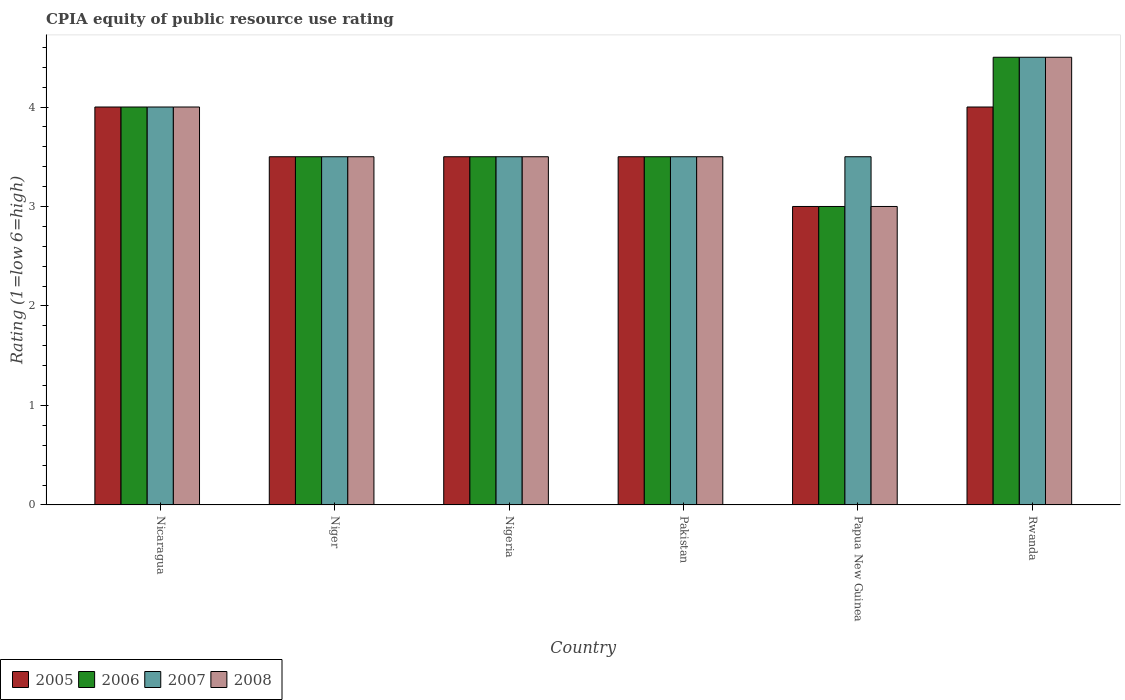Are the number of bars per tick equal to the number of legend labels?
Offer a terse response. Yes. Are the number of bars on each tick of the X-axis equal?
Ensure brevity in your answer.  Yes. How many bars are there on the 6th tick from the left?
Provide a succinct answer. 4. What is the label of the 5th group of bars from the left?
Provide a succinct answer. Papua New Guinea. In how many cases, is the number of bars for a given country not equal to the number of legend labels?
Provide a succinct answer. 0. What is the CPIA rating in 2005 in Rwanda?
Provide a short and direct response. 4. Across all countries, what is the minimum CPIA rating in 2006?
Provide a succinct answer. 3. In which country was the CPIA rating in 2005 maximum?
Offer a terse response. Nicaragua. In which country was the CPIA rating in 2006 minimum?
Keep it short and to the point. Papua New Guinea. What is the total CPIA rating in 2006 in the graph?
Provide a short and direct response. 22. What is the difference between the CPIA rating in 2007 in Nigeria and that in Rwanda?
Your answer should be very brief. -1. What is the difference between the CPIA rating in 2005 in Pakistan and the CPIA rating in 2006 in Niger?
Offer a very short reply. 0. What is the average CPIA rating in 2006 per country?
Provide a succinct answer. 3.67. What is the difference between the CPIA rating of/in 2006 and CPIA rating of/in 2005 in Pakistan?
Offer a very short reply. 0. What is the ratio of the CPIA rating in 2007 in Nicaragua to that in Niger?
Give a very brief answer. 1.14. Is the CPIA rating in 2008 in Niger less than that in Rwanda?
Provide a short and direct response. Yes. Is the sum of the CPIA rating in 2005 in Nicaragua and Niger greater than the maximum CPIA rating in 2007 across all countries?
Give a very brief answer. Yes. What does the 1st bar from the left in Pakistan represents?
Keep it short and to the point. 2005. What does the 1st bar from the right in Pakistan represents?
Offer a very short reply. 2008. How many bars are there?
Give a very brief answer. 24. How many countries are there in the graph?
Keep it short and to the point. 6. What is the difference between two consecutive major ticks on the Y-axis?
Provide a succinct answer. 1. Does the graph contain any zero values?
Your response must be concise. No. What is the title of the graph?
Provide a succinct answer. CPIA equity of public resource use rating. What is the label or title of the X-axis?
Offer a very short reply. Country. What is the Rating (1=low 6=high) in 2005 in Nicaragua?
Provide a succinct answer. 4. What is the Rating (1=low 6=high) in 2007 in Nicaragua?
Your response must be concise. 4. What is the Rating (1=low 6=high) of 2005 in Niger?
Your answer should be compact. 3.5. What is the Rating (1=low 6=high) in 2006 in Niger?
Give a very brief answer. 3.5. What is the Rating (1=low 6=high) of 2007 in Niger?
Offer a terse response. 3.5. What is the Rating (1=low 6=high) in 2006 in Nigeria?
Offer a terse response. 3.5. What is the Rating (1=low 6=high) in 2008 in Nigeria?
Keep it short and to the point. 3.5. What is the Rating (1=low 6=high) of 2005 in Pakistan?
Provide a succinct answer. 3.5. What is the Rating (1=low 6=high) in 2005 in Papua New Guinea?
Keep it short and to the point. 3. What is the Rating (1=low 6=high) of 2006 in Papua New Guinea?
Make the answer very short. 3. What is the Rating (1=low 6=high) in 2007 in Papua New Guinea?
Your answer should be compact. 3.5. What is the Rating (1=low 6=high) of 2008 in Papua New Guinea?
Give a very brief answer. 3. What is the Rating (1=low 6=high) of 2006 in Rwanda?
Provide a short and direct response. 4.5. Across all countries, what is the maximum Rating (1=low 6=high) in 2007?
Provide a short and direct response. 4.5. Across all countries, what is the maximum Rating (1=low 6=high) in 2008?
Offer a terse response. 4.5. Across all countries, what is the minimum Rating (1=low 6=high) of 2005?
Keep it short and to the point. 3. Across all countries, what is the minimum Rating (1=low 6=high) of 2006?
Keep it short and to the point. 3. Across all countries, what is the minimum Rating (1=low 6=high) of 2007?
Offer a terse response. 3.5. Across all countries, what is the minimum Rating (1=low 6=high) in 2008?
Your response must be concise. 3. What is the total Rating (1=low 6=high) of 2008 in the graph?
Ensure brevity in your answer.  22. What is the difference between the Rating (1=low 6=high) of 2005 in Nicaragua and that in Niger?
Your response must be concise. 0.5. What is the difference between the Rating (1=low 6=high) in 2007 in Nicaragua and that in Niger?
Make the answer very short. 0.5. What is the difference between the Rating (1=low 6=high) of 2005 in Nicaragua and that in Nigeria?
Provide a succinct answer. 0.5. What is the difference between the Rating (1=low 6=high) in 2007 in Nicaragua and that in Nigeria?
Keep it short and to the point. 0.5. What is the difference between the Rating (1=low 6=high) in 2008 in Nicaragua and that in Nigeria?
Provide a succinct answer. 0.5. What is the difference between the Rating (1=low 6=high) in 2006 in Nicaragua and that in Pakistan?
Make the answer very short. 0.5. What is the difference between the Rating (1=low 6=high) of 2007 in Nicaragua and that in Pakistan?
Make the answer very short. 0.5. What is the difference between the Rating (1=low 6=high) in 2008 in Nicaragua and that in Pakistan?
Make the answer very short. 0.5. What is the difference between the Rating (1=low 6=high) of 2006 in Nicaragua and that in Papua New Guinea?
Make the answer very short. 1. What is the difference between the Rating (1=low 6=high) of 2007 in Nicaragua and that in Papua New Guinea?
Give a very brief answer. 0.5. What is the difference between the Rating (1=low 6=high) in 2005 in Nicaragua and that in Rwanda?
Offer a terse response. 0. What is the difference between the Rating (1=low 6=high) in 2008 in Nicaragua and that in Rwanda?
Your answer should be very brief. -0.5. What is the difference between the Rating (1=low 6=high) of 2007 in Niger and that in Nigeria?
Offer a terse response. 0. What is the difference between the Rating (1=low 6=high) of 2005 in Niger and that in Pakistan?
Your response must be concise. 0. What is the difference between the Rating (1=low 6=high) in 2006 in Niger and that in Pakistan?
Offer a very short reply. 0. What is the difference between the Rating (1=low 6=high) in 2005 in Niger and that in Papua New Guinea?
Give a very brief answer. 0.5. What is the difference between the Rating (1=low 6=high) in 2007 in Niger and that in Papua New Guinea?
Offer a very short reply. 0. What is the difference between the Rating (1=low 6=high) in 2006 in Niger and that in Rwanda?
Provide a short and direct response. -1. What is the difference between the Rating (1=low 6=high) in 2008 in Niger and that in Rwanda?
Ensure brevity in your answer.  -1. What is the difference between the Rating (1=low 6=high) in 2005 in Nigeria and that in Pakistan?
Keep it short and to the point. 0. What is the difference between the Rating (1=low 6=high) of 2006 in Nigeria and that in Pakistan?
Your answer should be very brief. 0. What is the difference between the Rating (1=low 6=high) of 2007 in Nigeria and that in Pakistan?
Offer a terse response. 0. What is the difference between the Rating (1=low 6=high) of 2005 in Nigeria and that in Papua New Guinea?
Your answer should be compact. 0.5. What is the difference between the Rating (1=low 6=high) in 2007 in Nigeria and that in Papua New Guinea?
Provide a short and direct response. 0. What is the difference between the Rating (1=low 6=high) in 2006 in Nigeria and that in Rwanda?
Provide a succinct answer. -1. What is the difference between the Rating (1=low 6=high) in 2008 in Nigeria and that in Rwanda?
Your answer should be very brief. -1. What is the difference between the Rating (1=low 6=high) of 2005 in Pakistan and that in Papua New Guinea?
Provide a short and direct response. 0.5. What is the difference between the Rating (1=low 6=high) of 2007 in Pakistan and that in Papua New Guinea?
Offer a terse response. 0. What is the difference between the Rating (1=low 6=high) in 2005 in Pakistan and that in Rwanda?
Give a very brief answer. -0.5. What is the difference between the Rating (1=low 6=high) of 2007 in Pakistan and that in Rwanda?
Your answer should be compact. -1. What is the difference between the Rating (1=low 6=high) of 2008 in Pakistan and that in Rwanda?
Your answer should be very brief. -1. What is the difference between the Rating (1=low 6=high) in 2005 in Papua New Guinea and that in Rwanda?
Offer a very short reply. -1. What is the difference between the Rating (1=low 6=high) in 2006 in Papua New Guinea and that in Rwanda?
Your answer should be very brief. -1.5. What is the difference between the Rating (1=low 6=high) of 2007 in Papua New Guinea and that in Rwanda?
Ensure brevity in your answer.  -1. What is the difference between the Rating (1=low 6=high) of 2005 in Nicaragua and the Rating (1=low 6=high) of 2006 in Niger?
Offer a very short reply. 0.5. What is the difference between the Rating (1=low 6=high) of 2005 in Nicaragua and the Rating (1=low 6=high) of 2007 in Niger?
Give a very brief answer. 0.5. What is the difference between the Rating (1=low 6=high) in 2006 in Nicaragua and the Rating (1=low 6=high) in 2008 in Niger?
Make the answer very short. 0.5. What is the difference between the Rating (1=low 6=high) of 2007 in Nicaragua and the Rating (1=low 6=high) of 2008 in Niger?
Your answer should be compact. 0.5. What is the difference between the Rating (1=low 6=high) of 2005 in Nicaragua and the Rating (1=low 6=high) of 2007 in Nigeria?
Ensure brevity in your answer.  0.5. What is the difference between the Rating (1=low 6=high) in 2005 in Nicaragua and the Rating (1=low 6=high) in 2006 in Pakistan?
Your response must be concise. 0.5. What is the difference between the Rating (1=low 6=high) of 2006 in Nicaragua and the Rating (1=low 6=high) of 2007 in Pakistan?
Your answer should be very brief. 0.5. What is the difference between the Rating (1=low 6=high) of 2007 in Nicaragua and the Rating (1=low 6=high) of 2008 in Pakistan?
Ensure brevity in your answer.  0.5. What is the difference between the Rating (1=low 6=high) in 2005 in Nicaragua and the Rating (1=low 6=high) in 2006 in Papua New Guinea?
Provide a succinct answer. 1. What is the difference between the Rating (1=low 6=high) of 2005 in Nicaragua and the Rating (1=low 6=high) of 2007 in Papua New Guinea?
Provide a succinct answer. 0.5. What is the difference between the Rating (1=low 6=high) in 2005 in Nicaragua and the Rating (1=low 6=high) in 2008 in Papua New Guinea?
Your answer should be very brief. 1. What is the difference between the Rating (1=low 6=high) in 2005 in Nicaragua and the Rating (1=low 6=high) in 2006 in Rwanda?
Your response must be concise. -0.5. What is the difference between the Rating (1=low 6=high) of 2005 in Nicaragua and the Rating (1=low 6=high) of 2007 in Rwanda?
Provide a short and direct response. -0.5. What is the difference between the Rating (1=low 6=high) of 2005 in Nicaragua and the Rating (1=low 6=high) of 2008 in Rwanda?
Ensure brevity in your answer.  -0.5. What is the difference between the Rating (1=low 6=high) of 2006 in Nicaragua and the Rating (1=low 6=high) of 2007 in Rwanda?
Offer a very short reply. -0.5. What is the difference between the Rating (1=low 6=high) in 2006 in Nicaragua and the Rating (1=low 6=high) in 2008 in Rwanda?
Ensure brevity in your answer.  -0.5. What is the difference between the Rating (1=low 6=high) in 2005 in Niger and the Rating (1=low 6=high) in 2007 in Nigeria?
Offer a very short reply. 0. What is the difference between the Rating (1=low 6=high) in 2005 in Niger and the Rating (1=low 6=high) in 2008 in Nigeria?
Provide a succinct answer. 0. What is the difference between the Rating (1=low 6=high) of 2006 in Niger and the Rating (1=low 6=high) of 2007 in Nigeria?
Ensure brevity in your answer.  0. What is the difference between the Rating (1=low 6=high) of 2007 in Niger and the Rating (1=low 6=high) of 2008 in Nigeria?
Keep it short and to the point. 0. What is the difference between the Rating (1=low 6=high) in 2005 in Niger and the Rating (1=low 6=high) in 2006 in Pakistan?
Your response must be concise. 0. What is the difference between the Rating (1=low 6=high) of 2005 in Niger and the Rating (1=low 6=high) of 2007 in Pakistan?
Keep it short and to the point. 0. What is the difference between the Rating (1=low 6=high) in 2006 in Niger and the Rating (1=low 6=high) in 2007 in Pakistan?
Ensure brevity in your answer.  0. What is the difference between the Rating (1=low 6=high) in 2007 in Niger and the Rating (1=low 6=high) in 2008 in Pakistan?
Provide a short and direct response. 0. What is the difference between the Rating (1=low 6=high) in 2005 in Niger and the Rating (1=low 6=high) in 2006 in Papua New Guinea?
Offer a terse response. 0.5. What is the difference between the Rating (1=low 6=high) in 2006 in Niger and the Rating (1=low 6=high) in 2008 in Papua New Guinea?
Ensure brevity in your answer.  0.5. What is the difference between the Rating (1=low 6=high) in 2005 in Niger and the Rating (1=low 6=high) in 2006 in Rwanda?
Your answer should be compact. -1. What is the difference between the Rating (1=low 6=high) of 2005 in Niger and the Rating (1=low 6=high) of 2007 in Rwanda?
Ensure brevity in your answer.  -1. What is the difference between the Rating (1=low 6=high) in 2005 in Niger and the Rating (1=low 6=high) in 2008 in Rwanda?
Make the answer very short. -1. What is the difference between the Rating (1=low 6=high) of 2006 in Niger and the Rating (1=low 6=high) of 2008 in Rwanda?
Provide a short and direct response. -1. What is the difference between the Rating (1=low 6=high) in 2007 in Niger and the Rating (1=low 6=high) in 2008 in Rwanda?
Offer a very short reply. -1. What is the difference between the Rating (1=low 6=high) of 2005 in Nigeria and the Rating (1=low 6=high) of 2006 in Pakistan?
Your response must be concise. 0. What is the difference between the Rating (1=low 6=high) in 2005 in Nigeria and the Rating (1=low 6=high) in 2007 in Pakistan?
Make the answer very short. 0. What is the difference between the Rating (1=low 6=high) of 2006 in Nigeria and the Rating (1=low 6=high) of 2008 in Pakistan?
Offer a terse response. 0. What is the difference between the Rating (1=low 6=high) of 2007 in Nigeria and the Rating (1=low 6=high) of 2008 in Pakistan?
Your answer should be compact. 0. What is the difference between the Rating (1=low 6=high) in 2005 in Nigeria and the Rating (1=low 6=high) in 2006 in Papua New Guinea?
Provide a short and direct response. 0.5. What is the difference between the Rating (1=low 6=high) in 2005 in Nigeria and the Rating (1=low 6=high) in 2007 in Papua New Guinea?
Provide a short and direct response. 0. What is the difference between the Rating (1=low 6=high) in 2005 in Nigeria and the Rating (1=low 6=high) in 2008 in Papua New Guinea?
Offer a very short reply. 0.5. What is the difference between the Rating (1=low 6=high) of 2005 in Pakistan and the Rating (1=low 6=high) of 2008 in Papua New Guinea?
Offer a very short reply. 0.5. What is the difference between the Rating (1=low 6=high) in 2005 in Pakistan and the Rating (1=low 6=high) in 2006 in Rwanda?
Offer a very short reply. -1. What is the difference between the Rating (1=low 6=high) in 2005 in Pakistan and the Rating (1=low 6=high) in 2007 in Rwanda?
Your answer should be compact. -1. What is the difference between the Rating (1=low 6=high) in 2005 in Papua New Guinea and the Rating (1=low 6=high) in 2006 in Rwanda?
Your response must be concise. -1.5. What is the difference between the Rating (1=low 6=high) of 2005 in Papua New Guinea and the Rating (1=low 6=high) of 2007 in Rwanda?
Your answer should be compact. -1.5. What is the difference between the Rating (1=low 6=high) of 2006 in Papua New Guinea and the Rating (1=low 6=high) of 2007 in Rwanda?
Your answer should be compact. -1.5. What is the difference between the Rating (1=low 6=high) of 2007 in Papua New Guinea and the Rating (1=low 6=high) of 2008 in Rwanda?
Keep it short and to the point. -1. What is the average Rating (1=low 6=high) in 2005 per country?
Offer a terse response. 3.58. What is the average Rating (1=low 6=high) in 2006 per country?
Offer a terse response. 3.67. What is the average Rating (1=low 6=high) of 2007 per country?
Provide a succinct answer. 3.75. What is the average Rating (1=low 6=high) of 2008 per country?
Offer a terse response. 3.67. What is the difference between the Rating (1=low 6=high) of 2005 and Rating (1=low 6=high) of 2007 in Nicaragua?
Provide a short and direct response. 0. What is the difference between the Rating (1=low 6=high) in 2006 and Rating (1=low 6=high) in 2007 in Nicaragua?
Your answer should be very brief. 0. What is the difference between the Rating (1=low 6=high) of 2006 and Rating (1=low 6=high) of 2008 in Nicaragua?
Ensure brevity in your answer.  0. What is the difference between the Rating (1=low 6=high) in 2007 and Rating (1=low 6=high) in 2008 in Nicaragua?
Provide a succinct answer. 0. What is the difference between the Rating (1=low 6=high) of 2005 and Rating (1=low 6=high) of 2006 in Niger?
Offer a very short reply. 0. What is the difference between the Rating (1=low 6=high) of 2005 and Rating (1=low 6=high) of 2007 in Niger?
Give a very brief answer. 0. What is the difference between the Rating (1=low 6=high) in 2007 and Rating (1=low 6=high) in 2008 in Niger?
Your answer should be very brief. 0. What is the difference between the Rating (1=low 6=high) of 2005 and Rating (1=low 6=high) of 2006 in Nigeria?
Keep it short and to the point. 0. What is the difference between the Rating (1=low 6=high) in 2005 and Rating (1=low 6=high) in 2007 in Nigeria?
Your answer should be very brief. 0. What is the difference between the Rating (1=low 6=high) of 2005 and Rating (1=low 6=high) of 2008 in Nigeria?
Keep it short and to the point. 0. What is the difference between the Rating (1=low 6=high) in 2006 and Rating (1=low 6=high) in 2008 in Nigeria?
Offer a terse response. 0. What is the difference between the Rating (1=low 6=high) in 2007 and Rating (1=low 6=high) in 2008 in Nigeria?
Ensure brevity in your answer.  0. What is the difference between the Rating (1=low 6=high) of 2005 and Rating (1=low 6=high) of 2006 in Pakistan?
Your response must be concise. 0. What is the difference between the Rating (1=low 6=high) of 2005 and Rating (1=low 6=high) of 2007 in Pakistan?
Make the answer very short. 0. What is the difference between the Rating (1=low 6=high) in 2006 and Rating (1=low 6=high) in 2007 in Pakistan?
Your answer should be compact. 0. What is the difference between the Rating (1=low 6=high) in 2005 and Rating (1=low 6=high) in 2006 in Papua New Guinea?
Give a very brief answer. 0. What is the difference between the Rating (1=low 6=high) in 2005 and Rating (1=low 6=high) in 2006 in Rwanda?
Make the answer very short. -0.5. What is the difference between the Rating (1=low 6=high) in 2007 and Rating (1=low 6=high) in 2008 in Rwanda?
Your answer should be very brief. 0. What is the ratio of the Rating (1=low 6=high) in 2006 in Nicaragua to that in Niger?
Offer a terse response. 1.14. What is the ratio of the Rating (1=low 6=high) in 2007 in Nicaragua to that in Niger?
Your answer should be compact. 1.14. What is the ratio of the Rating (1=low 6=high) of 2005 in Nicaragua to that in Nigeria?
Provide a succinct answer. 1.14. What is the ratio of the Rating (1=low 6=high) of 2008 in Nicaragua to that in Nigeria?
Offer a terse response. 1.14. What is the ratio of the Rating (1=low 6=high) of 2007 in Nicaragua to that in Pakistan?
Your response must be concise. 1.14. What is the ratio of the Rating (1=low 6=high) of 2008 in Nicaragua to that in Pakistan?
Your answer should be very brief. 1.14. What is the ratio of the Rating (1=low 6=high) in 2005 in Nicaragua to that in Papua New Guinea?
Ensure brevity in your answer.  1.33. What is the ratio of the Rating (1=low 6=high) of 2007 in Nicaragua to that in Papua New Guinea?
Your answer should be compact. 1.14. What is the ratio of the Rating (1=low 6=high) of 2006 in Nicaragua to that in Rwanda?
Ensure brevity in your answer.  0.89. What is the ratio of the Rating (1=low 6=high) of 2007 in Nicaragua to that in Rwanda?
Your response must be concise. 0.89. What is the ratio of the Rating (1=low 6=high) of 2007 in Niger to that in Nigeria?
Ensure brevity in your answer.  1. What is the ratio of the Rating (1=low 6=high) of 2008 in Niger to that in Nigeria?
Give a very brief answer. 1. What is the ratio of the Rating (1=low 6=high) in 2007 in Niger to that in Pakistan?
Keep it short and to the point. 1. What is the ratio of the Rating (1=low 6=high) of 2005 in Niger to that in Papua New Guinea?
Ensure brevity in your answer.  1.17. What is the ratio of the Rating (1=low 6=high) of 2007 in Niger to that in Papua New Guinea?
Your answer should be compact. 1. What is the ratio of the Rating (1=low 6=high) in 2006 in Niger to that in Rwanda?
Make the answer very short. 0.78. What is the ratio of the Rating (1=low 6=high) in 2007 in Nigeria to that in Papua New Guinea?
Offer a terse response. 1. What is the ratio of the Rating (1=low 6=high) of 2006 in Nigeria to that in Rwanda?
Your response must be concise. 0.78. What is the ratio of the Rating (1=low 6=high) in 2007 in Nigeria to that in Rwanda?
Provide a short and direct response. 0.78. What is the ratio of the Rating (1=low 6=high) in 2008 in Nigeria to that in Rwanda?
Your answer should be compact. 0.78. What is the ratio of the Rating (1=low 6=high) of 2006 in Pakistan to that in Papua New Guinea?
Offer a very short reply. 1.17. What is the ratio of the Rating (1=low 6=high) of 2005 in Pakistan to that in Rwanda?
Your answer should be compact. 0.88. What is the ratio of the Rating (1=low 6=high) in 2007 in Pakistan to that in Rwanda?
Offer a very short reply. 0.78. What is the ratio of the Rating (1=low 6=high) in 2005 in Papua New Guinea to that in Rwanda?
Provide a succinct answer. 0.75. What is the ratio of the Rating (1=low 6=high) of 2007 in Papua New Guinea to that in Rwanda?
Provide a short and direct response. 0.78. What is the difference between the highest and the second highest Rating (1=low 6=high) in 2005?
Your answer should be compact. 0. What is the difference between the highest and the second highest Rating (1=low 6=high) of 2007?
Give a very brief answer. 0.5. What is the difference between the highest and the lowest Rating (1=low 6=high) in 2005?
Your answer should be compact. 1. 